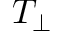<formula> <loc_0><loc_0><loc_500><loc_500>T _ { \perp }</formula> 